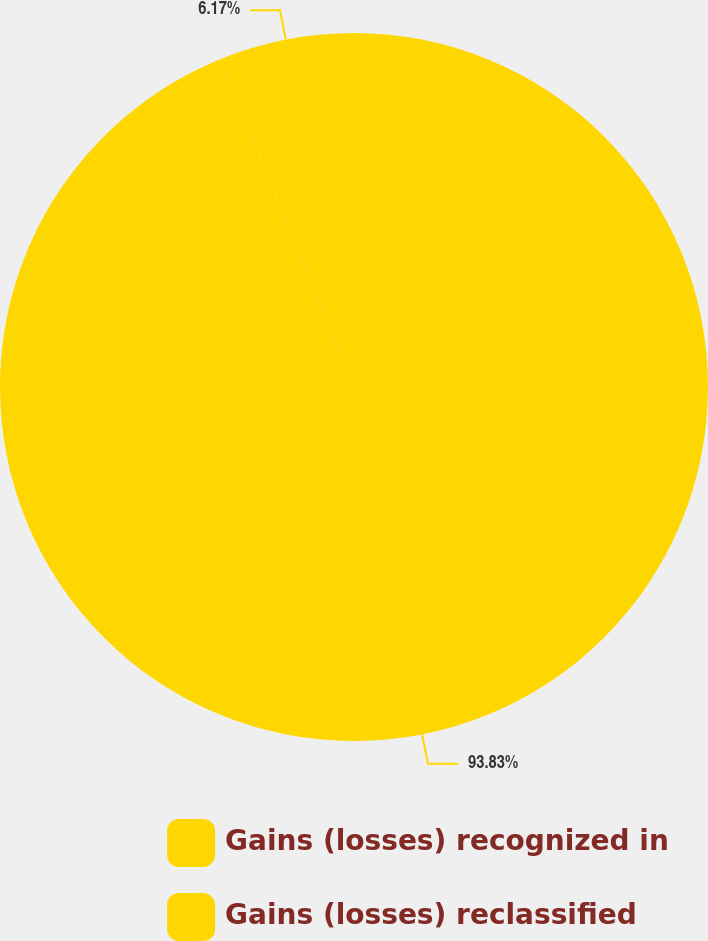Convert chart. <chart><loc_0><loc_0><loc_500><loc_500><pie_chart><fcel>Gains (losses) recognized in<fcel>Gains (losses) reclassified<nl><fcel>93.83%<fcel>6.17%<nl></chart> 